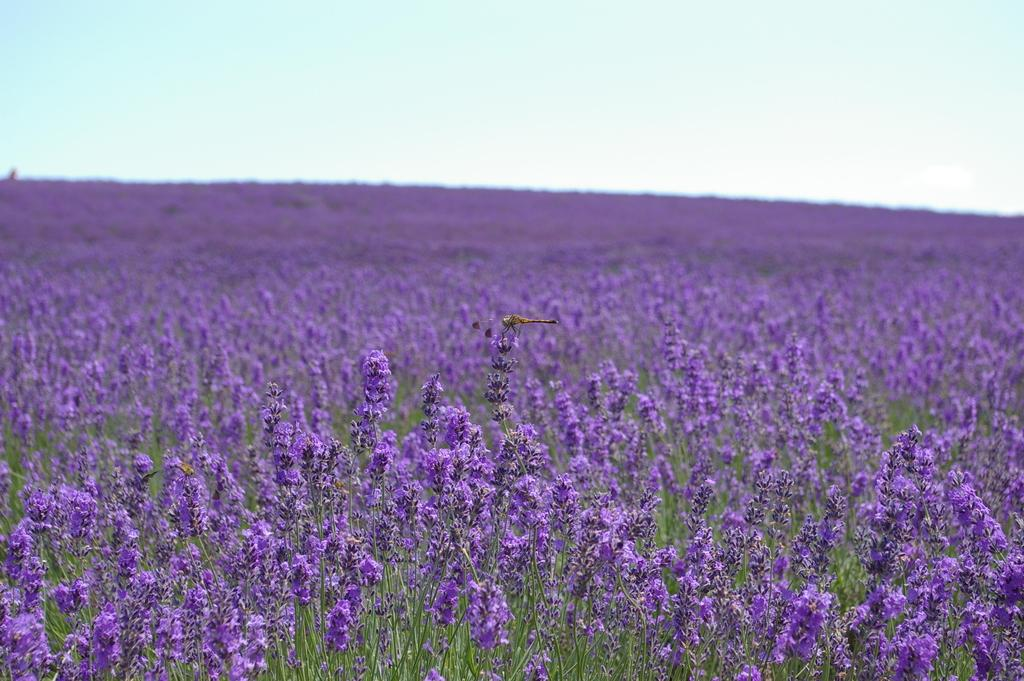What is the main subject in the middle of the image? There is a dragonfly in the middle of the image. What type of vegetation can be seen in the background of the image? There are plants with flowers in the background of the image. What is visible at the top of the image? The sky is visible at the top of the image. How does the dragonfly maintain its balance while walking on the front of the image? Dragonflies do not walk; they fly. Additionally, the image does not depict the dragonfly walking or maintaining balance, as it is shown in flight. 